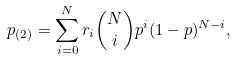Convert formula to latex. <formula><loc_0><loc_0><loc_500><loc_500>p _ { ( 2 ) } = \sum ^ { N } _ { i = 0 } { r _ { i } { N \choose i } p ^ { i } ( 1 - p ) ^ { N - i } } ,</formula> 